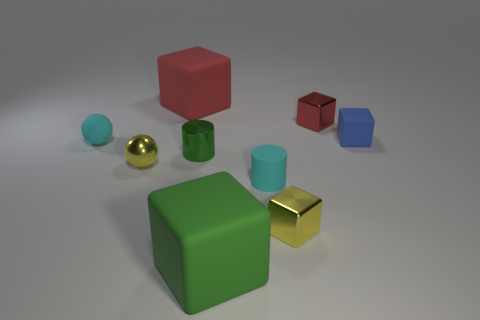Subtract all green cubes. How many cubes are left? 4 Subtract all tiny yellow metal cubes. How many cubes are left? 4 Subtract all purple cubes. Subtract all gray spheres. How many cubes are left? 5 Add 1 blue rubber objects. How many objects exist? 10 Subtract all cylinders. How many objects are left? 7 Subtract 0 blue spheres. How many objects are left? 9 Subtract all metal spheres. Subtract all matte objects. How many objects are left? 3 Add 3 yellow things. How many yellow things are left? 5 Add 6 yellow blocks. How many yellow blocks exist? 7 